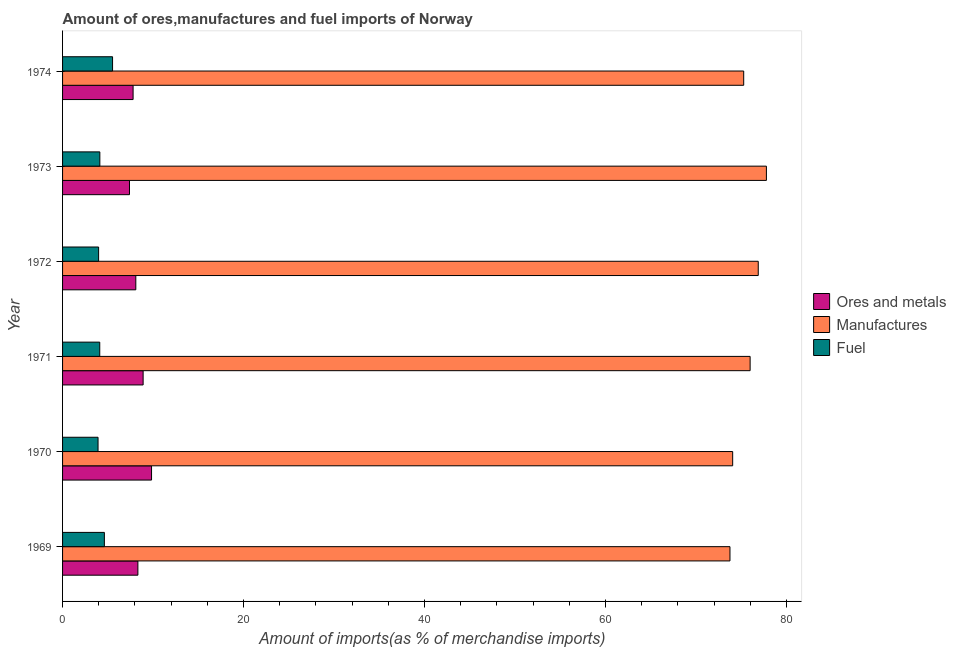How many different coloured bars are there?
Offer a very short reply. 3. How many groups of bars are there?
Provide a succinct answer. 6. Are the number of bars per tick equal to the number of legend labels?
Offer a terse response. Yes. How many bars are there on the 6th tick from the top?
Keep it short and to the point. 3. In how many cases, is the number of bars for a given year not equal to the number of legend labels?
Keep it short and to the point. 0. What is the percentage of fuel imports in 1971?
Your answer should be compact. 4.11. Across all years, what is the maximum percentage of fuel imports?
Give a very brief answer. 5.52. Across all years, what is the minimum percentage of manufactures imports?
Your response must be concise. 73.75. In which year was the percentage of fuel imports maximum?
Your answer should be compact. 1974. What is the total percentage of fuel imports in the graph?
Give a very brief answer. 26.28. What is the difference between the percentage of ores and metals imports in 1969 and that in 1974?
Provide a short and direct response. 0.53. What is the difference between the percentage of manufactures imports in 1974 and the percentage of fuel imports in 1970?
Keep it short and to the point. 71.35. What is the average percentage of manufactures imports per year?
Your answer should be very brief. 75.62. In the year 1970, what is the difference between the percentage of fuel imports and percentage of manufactures imports?
Ensure brevity in your answer.  -70.13. In how many years, is the percentage of ores and metals imports greater than 32 %?
Your answer should be very brief. 0. What is the ratio of the percentage of ores and metals imports in 1970 to that in 1973?
Offer a terse response. 1.33. Is the difference between the percentage of manufactures imports in 1972 and 1973 greater than the difference between the percentage of fuel imports in 1972 and 1973?
Your answer should be very brief. No. What is the difference between the highest and the second highest percentage of manufactures imports?
Offer a terse response. 0.9. What is the difference between the highest and the lowest percentage of fuel imports?
Provide a succinct answer. 1.6. In how many years, is the percentage of fuel imports greater than the average percentage of fuel imports taken over all years?
Keep it short and to the point. 2. Is the sum of the percentage of fuel imports in 1970 and 1973 greater than the maximum percentage of manufactures imports across all years?
Ensure brevity in your answer.  No. What does the 1st bar from the top in 1971 represents?
Provide a short and direct response. Fuel. What does the 1st bar from the bottom in 1973 represents?
Ensure brevity in your answer.  Ores and metals. How many bars are there?
Offer a very short reply. 18. How many years are there in the graph?
Give a very brief answer. 6. What is the difference between two consecutive major ticks on the X-axis?
Offer a terse response. 20. Are the values on the major ticks of X-axis written in scientific E-notation?
Offer a very short reply. No. Does the graph contain grids?
Offer a terse response. No. How many legend labels are there?
Offer a very short reply. 3. How are the legend labels stacked?
Your response must be concise. Vertical. What is the title of the graph?
Keep it short and to the point. Amount of ores,manufactures and fuel imports of Norway. What is the label or title of the X-axis?
Offer a terse response. Amount of imports(as % of merchandise imports). What is the label or title of the Y-axis?
Make the answer very short. Year. What is the Amount of imports(as % of merchandise imports) in Ores and metals in 1969?
Keep it short and to the point. 8.32. What is the Amount of imports(as % of merchandise imports) of Manufactures in 1969?
Provide a succinct answer. 73.75. What is the Amount of imports(as % of merchandise imports) of Fuel in 1969?
Your answer should be very brief. 4.62. What is the Amount of imports(as % of merchandise imports) of Ores and metals in 1970?
Provide a succinct answer. 9.83. What is the Amount of imports(as % of merchandise imports) of Manufactures in 1970?
Ensure brevity in your answer.  74.05. What is the Amount of imports(as % of merchandise imports) in Fuel in 1970?
Make the answer very short. 3.92. What is the Amount of imports(as % of merchandise imports) in Ores and metals in 1971?
Give a very brief answer. 8.9. What is the Amount of imports(as % of merchandise imports) of Manufactures in 1971?
Your response must be concise. 75.98. What is the Amount of imports(as % of merchandise imports) in Fuel in 1971?
Offer a very short reply. 4.11. What is the Amount of imports(as % of merchandise imports) of Ores and metals in 1972?
Provide a short and direct response. 8.09. What is the Amount of imports(as % of merchandise imports) of Manufactures in 1972?
Keep it short and to the point. 76.88. What is the Amount of imports(as % of merchandise imports) of Fuel in 1972?
Your answer should be compact. 3.98. What is the Amount of imports(as % of merchandise imports) of Ores and metals in 1973?
Ensure brevity in your answer.  7.4. What is the Amount of imports(as % of merchandise imports) in Manufactures in 1973?
Your answer should be compact. 77.78. What is the Amount of imports(as % of merchandise imports) of Fuel in 1973?
Provide a short and direct response. 4.12. What is the Amount of imports(as % of merchandise imports) in Ores and metals in 1974?
Your answer should be compact. 7.79. What is the Amount of imports(as % of merchandise imports) in Manufactures in 1974?
Your response must be concise. 75.27. What is the Amount of imports(as % of merchandise imports) in Fuel in 1974?
Ensure brevity in your answer.  5.52. Across all years, what is the maximum Amount of imports(as % of merchandise imports) in Ores and metals?
Your answer should be compact. 9.83. Across all years, what is the maximum Amount of imports(as % of merchandise imports) of Manufactures?
Provide a succinct answer. 77.78. Across all years, what is the maximum Amount of imports(as % of merchandise imports) in Fuel?
Ensure brevity in your answer.  5.52. Across all years, what is the minimum Amount of imports(as % of merchandise imports) of Ores and metals?
Offer a terse response. 7.4. Across all years, what is the minimum Amount of imports(as % of merchandise imports) of Manufactures?
Offer a terse response. 73.75. Across all years, what is the minimum Amount of imports(as % of merchandise imports) in Fuel?
Make the answer very short. 3.92. What is the total Amount of imports(as % of merchandise imports) of Ores and metals in the graph?
Your response must be concise. 50.35. What is the total Amount of imports(as % of merchandise imports) in Manufactures in the graph?
Make the answer very short. 453.72. What is the total Amount of imports(as % of merchandise imports) of Fuel in the graph?
Keep it short and to the point. 26.28. What is the difference between the Amount of imports(as % of merchandise imports) of Ores and metals in 1969 and that in 1970?
Your response must be concise. -1.51. What is the difference between the Amount of imports(as % of merchandise imports) of Manufactures in 1969 and that in 1970?
Your answer should be very brief. -0.3. What is the difference between the Amount of imports(as % of merchandise imports) in Ores and metals in 1969 and that in 1971?
Your answer should be very brief. -0.58. What is the difference between the Amount of imports(as % of merchandise imports) in Manufactures in 1969 and that in 1971?
Make the answer very short. -2.23. What is the difference between the Amount of imports(as % of merchandise imports) in Fuel in 1969 and that in 1971?
Ensure brevity in your answer.  0.51. What is the difference between the Amount of imports(as % of merchandise imports) of Ores and metals in 1969 and that in 1972?
Your answer should be compact. 0.23. What is the difference between the Amount of imports(as % of merchandise imports) in Manufactures in 1969 and that in 1972?
Ensure brevity in your answer.  -3.13. What is the difference between the Amount of imports(as % of merchandise imports) in Fuel in 1969 and that in 1972?
Your answer should be compact. 0.64. What is the difference between the Amount of imports(as % of merchandise imports) in Ores and metals in 1969 and that in 1973?
Provide a short and direct response. 0.93. What is the difference between the Amount of imports(as % of merchandise imports) of Manufactures in 1969 and that in 1973?
Keep it short and to the point. -4.03. What is the difference between the Amount of imports(as % of merchandise imports) in Fuel in 1969 and that in 1973?
Your answer should be very brief. 0.5. What is the difference between the Amount of imports(as % of merchandise imports) in Ores and metals in 1969 and that in 1974?
Keep it short and to the point. 0.53. What is the difference between the Amount of imports(as % of merchandise imports) of Manufactures in 1969 and that in 1974?
Offer a very short reply. -1.52. What is the difference between the Amount of imports(as % of merchandise imports) in Fuel in 1969 and that in 1974?
Offer a terse response. -0.9. What is the difference between the Amount of imports(as % of merchandise imports) of Ores and metals in 1970 and that in 1971?
Offer a very short reply. 0.93. What is the difference between the Amount of imports(as % of merchandise imports) of Manufactures in 1970 and that in 1971?
Your response must be concise. -1.93. What is the difference between the Amount of imports(as % of merchandise imports) in Fuel in 1970 and that in 1971?
Provide a short and direct response. -0.19. What is the difference between the Amount of imports(as % of merchandise imports) in Ores and metals in 1970 and that in 1972?
Make the answer very short. 1.74. What is the difference between the Amount of imports(as % of merchandise imports) in Manufactures in 1970 and that in 1972?
Your answer should be very brief. -2.83. What is the difference between the Amount of imports(as % of merchandise imports) of Fuel in 1970 and that in 1972?
Offer a very short reply. -0.06. What is the difference between the Amount of imports(as % of merchandise imports) of Ores and metals in 1970 and that in 1973?
Give a very brief answer. 2.44. What is the difference between the Amount of imports(as % of merchandise imports) of Manufactures in 1970 and that in 1973?
Your response must be concise. -3.73. What is the difference between the Amount of imports(as % of merchandise imports) in Fuel in 1970 and that in 1973?
Give a very brief answer. -0.2. What is the difference between the Amount of imports(as % of merchandise imports) of Ores and metals in 1970 and that in 1974?
Your answer should be compact. 2.04. What is the difference between the Amount of imports(as % of merchandise imports) of Manufactures in 1970 and that in 1974?
Provide a short and direct response. -1.22. What is the difference between the Amount of imports(as % of merchandise imports) of Fuel in 1970 and that in 1974?
Make the answer very short. -1.6. What is the difference between the Amount of imports(as % of merchandise imports) of Ores and metals in 1971 and that in 1972?
Provide a succinct answer. 0.81. What is the difference between the Amount of imports(as % of merchandise imports) of Manufactures in 1971 and that in 1972?
Your answer should be compact. -0.9. What is the difference between the Amount of imports(as % of merchandise imports) in Fuel in 1971 and that in 1972?
Make the answer very short. 0.13. What is the difference between the Amount of imports(as % of merchandise imports) of Ores and metals in 1971 and that in 1973?
Your answer should be compact. 1.51. What is the difference between the Amount of imports(as % of merchandise imports) in Manufactures in 1971 and that in 1973?
Your response must be concise. -1.8. What is the difference between the Amount of imports(as % of merchandise imports) of Fuel in 1971 and that in 1973?
Make the answer very short. -0.01. What is the difference between the Amount of imports(as % of merchandise imports) of Ores and metals in 1971 and that in 1974?
Offer a very short reply. 1.11. What is the difference between the Amount of imports(as % of merchandise imports) of Manufactures in 1971 and that in 1974?
Give a very brief answer. 0.71. What is the difference between the Amount of imports(as % of merchandise imports) in Fuel in 1971 and that in 1974?
Offer a very short reply. -1.41. What is the difference between the Amount of imports(as % of merchandise imports) in Ores and metals in 1972 and that in 1973?
Your response must be concise. 0.7. What is the difference between the Amount of imports(as % of merchandise imports) of Manufactures in 1972 and that in 1973?
Make the answer very short. -0.9. What is the difference between the Amount of imports(as % of merchandise imports) of Fuel in 1972 and that in 1973?
Your response must be concise. -0.14. What is the difference between the Amount of imports(as % of merchandise imports) in Ores and metals in 1972 and that in 1974?
Your answer should be compact. 0.3. What is the difference between the Amount of imports(as % of merchandise imports) of Manufactures in 1972 and that in 1974?
Ensure brevity in your answer.  1.61. What is the difference between the Amount of imports(as % of merchandise imports) in Fuel in 1972 and that in 1974?
Provide a succinct answer. -1.54. What is the difference between the Amount of imports(as % of merchandise imports) in Ores and metals in 1973 and that in 1974?
Make the answer very short. -0.4. What is the difference between the Amount of imports(as % of merchandise imports) of Manufactures in 1973 and that in 1974?
Keep it short and to the point. 2.51. What is the difference between the Amount of imports(as % of merchandise imports) in Fuel in 1973 and that in 1974?
Your answer should be compact. -1.4. What is the difference between the Amount of imports(as % of merchandise imports) in Ores and metals in 1969 and the Amount of imports(as % of merchandise imports) in Manufactures in 1970?
Make the answer very short. -65.73. What is the difference between the Amount of imports(as % of merchandise imports) of Ores and metals in 1969 and the Amount of imports(as % of merchandise imports) of Fuel in 1970?
Ensure brevity in your answer.  4.4. What is the difference between the Amount of imports(as % of merchandise imports) in Manufactures in 1969 and the Amount of imports(as % of merchandise imports) in Fuel in 1970?
Your answer should be very brief. 69.83. What is the difference between the Amount of imports(as % of merchandise imports) of Ores and metals in 1969 and the Amount of imports(as % of merchandise imports) of Manufactures in 1971?
Provide a short and direct response. -67.66. What is the difference between the Amount of imports(as % of merchandise imports) of Ores and metals in 1969 and the Amount of imports(as % of merchandise imports) of Fuel in 1971?
Ensure brevity in your answer.  4.21. What is the difference between the Amount of imports(as % of merchandise imports) in Manufactures in 1969 and the Amount of imports(as % of merchandise imports) in Fuel in 1971?
Make the answer very short. 69.64. What is the difference between the Amount of imports(as % of merchandise imports) of Ores and metals in 1969 and the Amount of imports(as % of merchandise imports) of Manufactures in 1972?
Offer a terse response. -68.55. What is the difference between the Amount of imports(as % of merchandise imports) in Ores and metals in 1969 and the Amount of imports(as % of merchandise imports) in Fuel in 1972?
Give a very brief answer. 4.34. What is the difference between the Amount of imports(as % of merchandise imports) in Manufactures in 1969 and the Amount of imports(as % of merchandise imports) in Fuel in 1972?
Your answer should be very brief. 69.77. What is the difference between the Amount of imports(as % of merchandise imports) in Ores and metals in 1969 and the Amount of imports(as % of merchandise imports) in Manufactures in 1973?
Make the answer very short. -69.46. What is the difference between the Amount of imports(as % of merchandise imports) of Ores and metals in 1969 and the Amount of imports(as % of merchandise imports) of Fuel in 1973?
Make the answer very short. 4.2. What is the difference between the Amount of imports(as % of merchandise imports) in Manufactures in 1969 and the Amount of imports(as % of merchandise imports) in Fuel in 1973?
Provide a short and direct response. 69.63. What is the difference between the Amount of imports(as % of merchandise imports) of Ores and metals in 1969 and the Amount of imports(as % of merchandise imports) of Manufactures in 1974?
Offer a very short reply. -66.95. What is the difference between the Amount of imports(as % of merchandise imports) of Ores and metals in 1969 and the Amount of imports(as % of merchandise imports) of Fuel in 1974?
Make the answer very short. 2.8. What is the difference between the Amount of imports(as % of merchandise imports) in Manufactures in 1969 and the Amount of imports(as % of merchandise imports) in Fuel in 1974?
Provide a short and direct response. 68.23. What is the difference between the Amount of imports(as % of merchandise imports) of Ores and metals in 1970 and the Amount of imports(as % of merchandise imports) of Manufactures in 1971?
Provide a succinct answer. -66.15. What is the difference between the Amount of imports(as % of merchandise imports) in Ores and metals in 1970 and the Amount of imports(as % of merchandise imports) in Fuel in 1971?
Give a very brief answer. 5.72. What is the difference between the Amount of imports(as % of merchandise imports) in Manufactures in 1970 and the Amount of imports(as % of merchandise imports) in Fuel in 1971?
Your answer should be very brief. 69.94. What is the difference between the Amount of imports(as % of merchandise imports) in Ores and metals in 1970 and the Amount of imports(as % of merchandise imports) in Manufactures in 1972?
Offer a very short reply. -67.05. What is the difference between the Amount of imports(as % of merchandise imports) of Ores and metals in 1970 and the Amount of imports(as % of merchandise imports) of Fuel in 1972?
Offer a terse response. 5.85. What is the difference between the Amount of imports(as % of merchandise imports) in Manufactures in 1970 and the Amount of imports(as % of merchandise imports) in Fuel in 1972?
Make the answer very short. 70.07. What is the difference between the Amount of imports(as % of merchandise imports) in Ores and metals in 1970 and the Amount of imports(as % of merchandise imports) in Manufactures in 1973?
Keep it short and to the point. -67.95. What is the difference between the Amount of imports(as % of merchandise imports) in Ores and metals in 1970 and the Amount of imports(as % of merchandise imports) in Fuel in 1973?
Ensure brevity in your answer.  5.71. What is the difference between the Amount of imports(as % of merchandise imports) of Manufactures in 1970 and the Amount of imports(as % of merchandise imports) of Fuel in 1973?
Provide a succinct answer. 69.93. What is the difference between the Amount of imports(as % of merchandise imports) of Ores and metals in 1970 and the Amount of imports(as % of merchandise imports) of Manufactures in 1974?
Keep it short and to the point. -65.44. What is the difference between the Amount of imports(as % of merchandise imports) in Ores and metals in 1970 and the Amount of imports(as % of merchandise imports) in Fuel in 1974?
Give a very brief answer. 4.31. What is the difference between the Amount of imports(as % of merchandise imports) of Manufactures in 1970 and the Amount of imports(as % of merchandise imports) of Fuel in 1974?
Give a very brief answer. 68.53. What is the difference between the Amount of imports(as % of merchandise imports) of Ores and metals in 1971 and the Amount of imports(as % of merchandise imports) of Manufactures in 1972?
Keep it short and to the point. -67.98. What is the difference between the Amount of imports(as % of merchandise imports) in Ores and metals in 1971 and the Amount of imports(as % of merchandise imports) in Fuel in 1972?
Provide a short and direct response. 4.92. What is the difference between the Amount of imports(as % of merchandise imports) of Manufactures in 1971 and the Amount of imports(as % of merchandise imports) of Fuel in 1972?
Offer a terse response. 72. What is the difference between the Amount of imports(as % of merchandise imports) of Ores and metals in 1971 and the Amount of imports(as % of merchandise imports) of Manufactures in 1973?
Make the answer very short. -68.88. What is the difference between the Amount of imports(as % of merchandise imports) in Ores and metals in 1971 and the Amount of imports(as % of merchandise imports) in Fuel in 1973?
Provide a succinct answer. 4.78. What is the difference between the Amount of imports(as % of merchandise imports) of Manufactures in 1971 and the Amount of imports(as % of merchandise imports) of Fuel in 1973?
Your answer should be very brief. 71.86. What is the difference between the Amount of imports(as % of merchandise imports) of Ores and metals in 1971 and the Amount of imports(as % of merchandise imports) of Manufactures in 1974?
Offer a terse response. -66.37. What is the difference between the Amount of imports(as % of merchandise imports) in Ores and metals in 1971 and the Amount of imports(as % of merchandise imports) in Fuel in 1974?
Ensure brevity in your answer.  3.38. What is the difference between the Amount of imports(as % of merchandise imports) of Manufactures in 1971 and the Amount of imports(as % of merchandise imports) of Fuel in 1974?
Your answer should be compact. 70.46. What is the difference between the Amount of imports(as % of merchandise imports) in Ores and metals in 1972 and the Amount of imports(as % of merchandise imports) in Manufactures in 1973?
Offer a very short reply. -69.69. What is the difference between the Amount of imports(as % of merchandise imports) in Ores and metals in 1972 and the Amount of imports(as % of merchandise imports) in Fuel in 1973?
Offer a very short reply. 3.98. What is the difference between the Amount of imports(as % of merchandise imports) of Manufactures in 1972 and the Amount of imports(as % of merchandise imports) of Fuel in 1973?
Make the answer very short. 72.76. What is the difference between the Amount of imports(as % of merchandise imports) in Ores and metals in 1972 and the Amount of imports(as % of merchandise imports) in Manufactures in 1974?
Make the answer very short. -67.18. What is the difference between the Amount of imports(as % of merchandise imports) in Ores and metals in 1972 and the Amount of imports(as % of merchandise imports) in Fuel in 1974?
Keep it short and to the point. 2.57. What is the difference between the Amount of imports(as % of merchandise imports) in Manufactures in 1972 and the Amount of imports(as % of merchandise imports) in Fuel in 1974?
Offer a terse response. 71.36. What is the difference between the Amount of imports(as % of merchandise imports) in Ores and metals in 1973 and the Amount of imports(as % of merchandise imports) in Manufactures in 1974?
Ensure brevity in your answer.  -67.88. What is the difference between the Amount of imports(as % of merchandise imports) in Ores and metals in 1973 and the Amount of imports(as % of merchandise imports) in Fuel in 1974?
Offer a terse response. 1.87. What is the difference between the Amount of imports(as % of merchandise imports) in Manufactures in 1973 and the Amount of imports(as % of merchandise imports) in Fuel in 1974?
Keep it short and to the point. 72.26. What is the average Amount of imports(as % of merchandise imports) in Ores and metals per year?
Keep it short and to the point. 8.39. What is the average Amount of imports(as % of merchandise imports) in Manufactures per year?
Your answer should be compact. 75.62. What is the average Amount of imports(as % of merchandise imports) of Fuel per year?
Offer a terse response. 4.38. In the year 1969, what is the difference between the Amount of imports(as % of merchandise imports) of Ores and metals and Amount of imports(as % of merchandise imports) of Manufactures?
Give a very brief answer. -65.43. In the year 1969, what is the difference between the Amount of imports(as % of merchandise imports) in Ores and metals and Amount of imports(as % of merchandise imports) in Fuel?
Provide a short and direct response. 3.7. In the year 1969, what is the difference between the Amount of imports(as % of merchandise imports) in Manufactures and Amount of imports(as % of merchandise imports) in Fuel?
Your response must be concise. 69.13. In the year 1970, what is the difference between the Amount of imports(as % of merchandise imports) of Ores and metals and Amount of imports(as % of merchandise imports) of Manufactures?
Your response must be concise. -64.22. In the year 1970, what is the difference between the Amount of imports(as % of merchandise imports) in Ores and metals and Amount of imports(as % of merchandise imports) in Fuel?
Make the answer very short. 5.91. In the year 1970, what is the difference between the Amount of imports(as % of merchandise imports) in Manufactures and Amount of imports(as % of merchandise imports) in Fuel?
Offer a very short reply. 70.13. In the year 1971, what is the difference between the Amount of imports(as % of merchandise imports) of Ores and metals and Amount of imports(as % of merchandise imports) of Manufactures?
Your answer should be compact. -67.08. In the year 1971, what is the difference between the Amount of imports(as % of merchandise imports) in Ores and metals and Amount of imports(as % of merchandise imports) in Fuel?
Provide a short and direct response. 4.79. In the year 1971, what is the difference between the Amount of imports(as % of merchandise imports) of Manufactures and Amount of imports(as % of merchandise imports) of Fuel?
Offer a terse response. 71.87. In the year 1972, what is the difference between the Amount of imports(as % of merchandise imports) in Ores and metals and Amount of imports(as % of merchandise imports) in Manufactures?
Provide a succinct answer. -68.78. In the year 1972, what is the difference between the Amount of imports(as % of merchandise imports) in Ores and metals and Amount of imports(as % of merchandise imports) in Fuel?
Provide a short and direct response. 4.11. In the year 1972, what is the difference between the Amount of imports(as % of merchandise imports) in Manufactures and Amount of imports(as % of merchandise imports) in Fuel?
Ensure brevity in your answer.  72.9. In the year 1973, what is the difference between the Amount of imports(as % of merchandise imports) in Ores and metals and Amount of imports(as % of merchandise imports) in Manufactures?
Offer a terse response. -70.38. In the year 1973, what is the difference between the Amount of imports(as % of merchandise imports) of Ores and metals and Amount of imports(as % of merchandise imports) of Fuel?
Make the answer very short. 3.28. In the year 1973, what is the difference between the Amount of imports(as % of merchandise imports) of Manufactures and Amount of imports(as % of merchandise imports) of Fuel?
Provide a succinct answer. 73.66. In the year 1974, what is the difference between the Amount of imports(as % of merchandise imports) in Ores and metals and Amount of imports(as % of merchandise imports) in Manufactures?
Your answer should be very brief. -67.48. In the year 1974, what is the difference between the Amount of imports(as % of merchandise imports) of Ores and metals and Amount of imports(as % of merchandise imports) of Fuel?
Provide a short and direct response. 2.27. In the year 1974, what is the difference between the Amount of imports(as % of merchandise imports) in Manufactures and Amount of imports(as % of merchandise imports) in Fuel?
Your answer should be very brief. 69.75. What is the ratio of the Amount of imports(as % of merchandise imports) in Ores and metals in 1969 to that in 1970?
Provide a short and direct response. 0.85. What is the ratio of the Amount of imports(as % of merchandise imports) of Manufactures in 1969 to that in 1970?
Provide a succinct answer. 1. What is the ratio of the Amount of imports(as % of merchandise imports) in Fuel in 1969 to that in 1970?
Provide a short and direct response. 1.18. What is the ratio of the Amount of imports(as % of merchandise imports) of Ores and metals in 1969 to that in 1971?
Provide a short and direct response. 0.94. What is the ratio of the Amount of imports(as % of merchandise imports) in Manufactures in 1969 to that in 1971?
Provide a succinct answer. 0.97. What is the ratio of the Amount of imports(as % of merchandise imports) in Fuel in 1969 to that in 1971?
Your answer should be very brief. 1.12. What is the ratio of the Amount of imports(as % of merchandise imports) of Ores and metals in 1969 to that in 1972?
Provide a short and direct response. 1.03. What is the ratio of the Amount of imports(as % of merchandise imports) of Manufactures in 1969 to that in 1972?
Make the answer very short. 0.96. What is the ratio of the Amount of imports(as % of merchandise imports) of Fuel in 1969 to that in 1972?
Ensure brevity in your answer.  1.16. What is the ratio of the Amount of imports(as % of merchandise imports) in Ores and metals in 1969 to that in 1973?
Offer a terse response. 1.13. What is the ratio of the Amount of imports(as % of merchandise imports) of Manufactures in 1969 to that in 1973?
Provide a short and direct response. 0.95. What is the ratio of the Amount of imports(as % of merchandise imports) in Fuel in 1969 to that in 1973?
Make the answer very short. 1.12. What is the ratio of the Amount of imports(as % of merchandise imports) of Ores and metals in 1969 to that in 1974?
Your answer should be very brief. 1.07. What is the ratio of the Amount of imports(as % of merchandise imports) of Manufactures in 1969 to that in 1974?
Your response must be concise. 0.98. What is the ratio of the Amount of imports(as % of merchandise imports) of Fuel in 1969 to that in 1974?
Make the answer very short. 0.84. What is the ratio of the Amount of imports(as % of merchandise imports) in Ores and metals in 1970 to that in 1971?
Provide a succinct answer. 1.1. What is the ratio of the Amount of imports(as % of merchandise imports) in Manufactures in 1970 to that in 1971?
Provide a succinct answer. 0.97. What is the ratio of the Amount of imports(as % of merchandise imports) of Fuel in 1970 to that in 1971?
Provide a short and direct response. 0.95. What is the ratio of the Amount of imports(as % of merchandise imports) of Ores and metals in 1970 to that in 1972?
Your response must be concise. 1.21. What is the ratio of the Amount of imports(as % of merchandise imports) in Manufactures in 1970 to that in 1972?
Make the answer very short. 0.96. What is the ratio of the Amount of imports(as % of merchandise imports) in Fuel in 1970 to that in 1972?
Offer a very short reply. 0.98. What is the ratio of the Amount of imports(as % of merchandise imports) in Ores and metals in 1970 to that in 1973?
Your answer should be very brief. 1.33. What is the ratio of the Amount of imports(as % of merchandise imports) of Manufactures in 1970 to that in 1973?
Offer a terse response. 0.95. What is the ratio of the Amount of imports(as % of merchandise imports) of Fuel in 1970 to that in 1973?
Provide a short and direct response. 0.95. What is the ratio of the Amount of imports(as % of merchandise imports) in Ores and metals in 1970 to that in 1974?
Provide a short and direct response. 1.26. What is the ratio of the Amount of imports(as % of merchandise imports) in Manufactures in 1970 to that in 1974?
Your answer should be compact. 0.98. What is the ratio of the Amount of imports(as % of merchandise imports) of Fuel in 1970 to that in 1974?
Your answer should be compact. 0.71. What is the ratio of the Amount of imports(as % of merchandise imports) of Ores and metals in 1971 to that in 1972?
Your answer should be very brief. 1.1. What is the ratio of the Amount of imports(as % of merchandise imports) in Manufactures in 1971 to that in 1972?
Keep it short and to the point. 0.99. What is the ratio of the Amount of imports(as % of merchandise imports) in Fuel in 1971 to that in 1972?
Your response must be concise. 1.03. What is the ratio of the Amount of imports(as % of merchandise imports) in Ores and metals in 1971 to that in 1973?
Ensure brevity in your answer.  1.2. What is the ratio of the Amount of imports(as % of merchandise imports) in Manufactures in 1971 to that in 1973?
Provide a short and direct response. 0.98. What is the ratio of the Amount of imports(as % of merchandise imports) in Fuel in 1971 to that in 1973?
Offer a very short reply. 1. What is the ratio of the Amount of imports(as % of merchandise imports) of Ores and metals in 1971 to that in 1974?
Offer a terse response. 1.14. What is the ratio of the Amount of imports(as % of merchandise imports) of Manufactures in 1971 to that in 1974?
Keep it short and to the point. 1.01. What is the ratio of the Amount of imports(as % of merchandise imports) of Fuel in 1971 to that in 1974?
Ensure brevity in your answer.  0.74. What is the ratio of the Amount of imports(as % of merchandise imports) in Ores and metals in 1972 to that in 1973?
Your response must be concise. 1.09. What is the ratio of the Amount of imports(as % of merchandise imports) in Manufactures in 1972 to that in 1973?
Ensure brevity in your answer.  0.99. What is the ratio of the Amount of imports(as % of merchandise imports) of Fuel in 1972 to that in 1973?
Offer a very short reply. 0.97. What is the ratio of the Amount of imports(as % of merchandise imports) of Ores and metals in 1972 to that in 1974?
Keep it short and to the point. 1.04. What is the ratio of the Amount of imports(as % of merchandise imports) in Manufactures in 1972 to that in 1974?
Your answer should be very brief. 1.02. What is the ratio of the Amount of imports(as % of merchandise imports) in Fuel in 1972 to that in 1974?
Give a very brief answer. 0.72. What is the ratio of the Amount of imports(as % of merchandise imports) of Ores and metals in 1973 to that in 1974?
Give a very brief answer. 0.95. What is the ratio of the Amount of imports(as % of merchandise imports) of Manufactures in 1973 to that in 1974?
Make the answer very short. 1.03. What is the ratio of the Amount of imports(as % of merchandise imports) of Fuel in 1973 to that in 1974?
Ensure brevity in your answer.  0.75. What is the difference between the highest and the second highest Amount of imports(as % of merchandise imports) of Ores and metals?
Provide a succinct answer. 0.93. What is the difference between the highest and the second highest Amount of imports(as % of merchandise imports) of Manufactures?
Ensure brevity in your answer.  0.9. What is the difference between the highest and the second highest Amount of imports(as % of merchandise imports) in Fuel?
Provide a succinct answer. 0.9. What is the difference between the highest and the lowest Amount of imports(as % of merchandise imports) in Ores and metals?
Make the answer very short. 2.44. What is the difference between the highest and the lowest Amount of imports(as % of merchandise imports) of Manufactures?
Provide a succinct answer. 4.03. What is the difference between the highest and the lowest Amount of imports(as % of merchandise imports) of Fuel?
Offer a terse response. 1.6. 